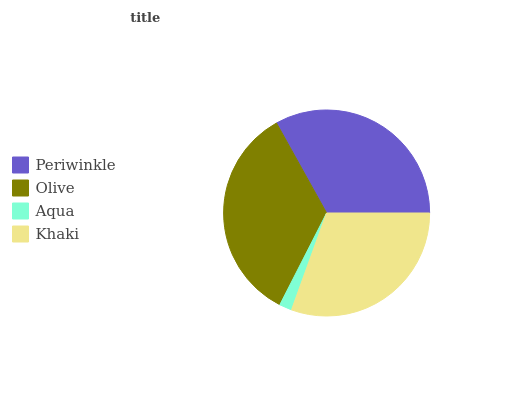Is Aqua the minimum?
Answer yes or no. Yes. Is Olive the maximum?
Answer yes or no. Yes. Is Olive the minimum?
Answer yes or no. No. Is Aqua the maximum?
Answer yes or no. No. Is Olive greater than Aqua?
Answer yes or no. Yes. Is Aqua less than Olive?
Answer yes or no. Yes. Is Aqua greater than Olive?
Answer yes or no. No. Is Olive less than Aqua?
Answer yes or no. No. Is Periwinkle the high median?
Answer yes or no. Yes. Is Khaki the low median?
Answer yes or no. Yes. Is Khaki the high median?
Answer yes or no. No. Is Periwinkle the low median?
Answer yes or no. No. 